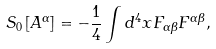<formula> <loc_0><loc_0><loc_500><loc_500>S _ { 0 } \left [ A ^ { \alpha } \right ] = - \frac { 1 } { 4 } \int d ^ { 4 } x F _ { \alpha \beta } F ^ { \alpha \beta } ,</formula> 